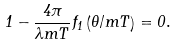<formula> <loc_0><loc_0><loc_500><loc_500>1 - \frac { 4 \pi } { \lambda m T } f _ { 1 } \left ( \theta / m T \right ) = 0 .</formula> 